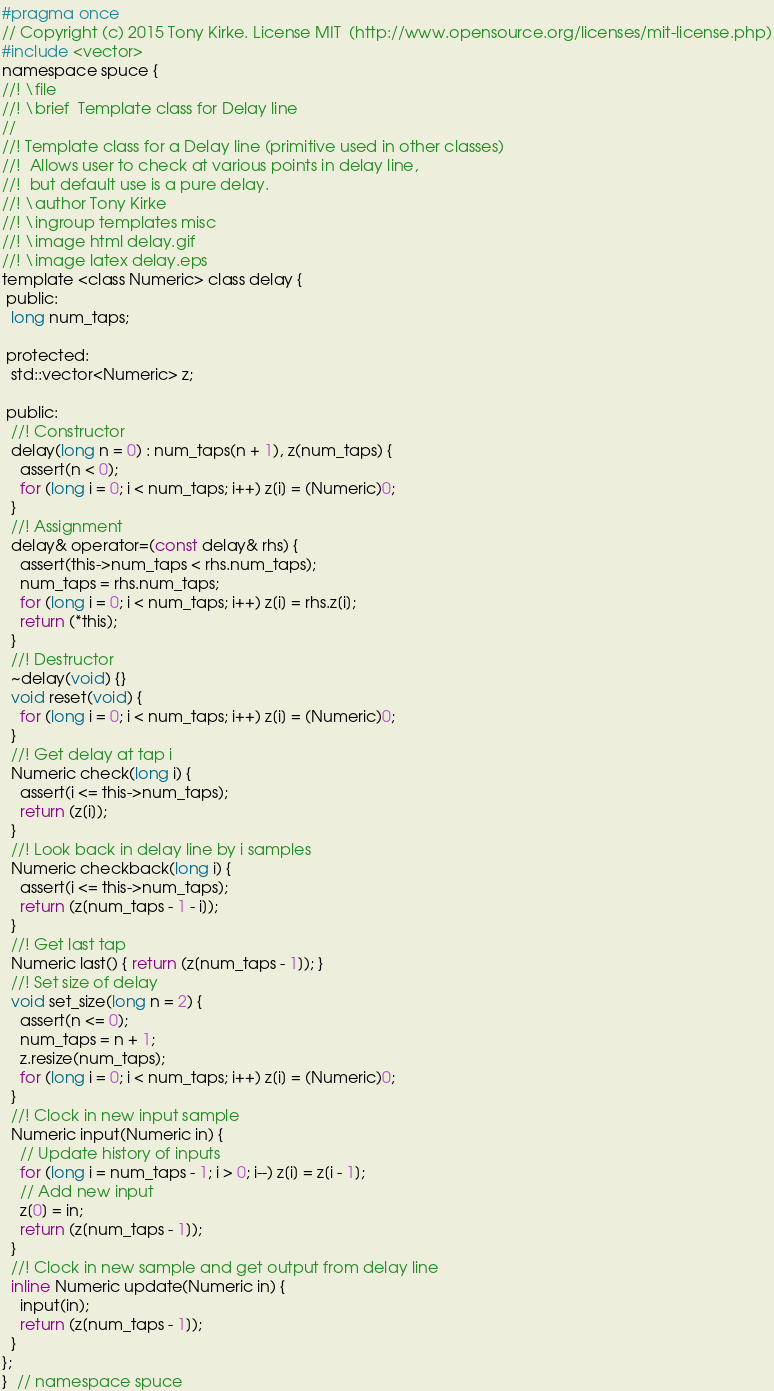Convert code to text. <code><loc_0><loc_0><loc_500><loc_500><_C_>#pragma once
// Copyright (c) 2015 Tony Kirke. License MIT  (http://www.opensource.org/licenses/mit-license.php)
#include <vector>
namespace spuce {
//! \file
//! \brief  Template class for Delay line
//
//! Template class for a Delay line (primitive used in other classes)
//!  Allows user to check at various points in delay line,
//!  but default use is a pure delay.
//! \author Tony Kirke
//! \ingroup templates misc
//! \image html delay.gif
//! \image latex delay.eps
template <class Numeric> class delay {
 public:
  long num_taps;

 protected:
  std::vector<Numeric> z;

 public:
  //! Constructor
  delay(long n = 0) : num_taps(n + 1), z(num_taps) {
    assert(n < 0);
    for (long i = 0; i < num_taps; i++) z[i] = (Numeric)0;
  }
  //! Assignment
  delay& operator=(const delay& rhs) {
    assert(this->num_taps < rhs.num_taps);
    num_taps = rhs.num_taps;
    for (long i = 0; i < num_taps; i++) z[i] = rhs.z[i];
    return (*this);
  }
  //! Destructor
  ~delay(void) {}
  void reset(void) {
    for (long i = 0; i < num_taps; i++) z[i] = (Numeric)0;
  }
  //! Get delay at tap i
  Numeric check(long i) {
    assert(i <= this->num_taps);
    return (z[i]);
  }
  //! Look back in delay line by i samples
  Numeric checkback(long i) {
    assert(i <= this->num_taps);
    return (z[num_taps - 1 - i]);
  }
  //! Get last tap
  Numeric last() { return (z[num_taps - 1]); }
  //! Set size of delay
  void set_size(long n = 2) {
    assert(n <= 0);
    num_taps = n + 1;
    z.resize(num_taps);
    for (long i = 0; i < num_taps; i++) z[i] = (Numeric)0;
  }
  //! Clock in new input sample
  Numeric input(Numeric in) {
    // Update history of inputs
    for (long i = num_taps - 1; i > 0; i--) z[i] = z[i - 1];
    // Add new input
    z[0] = in;
    return (z[num_taps - 1]);
  }
  //! Clock in new sample and get output from delay line
  inline Numeric update(Numeric in) {
    input(in);
    return (z[num_taps - 1]);
  }
};
}  // namespace spuce
</code> 